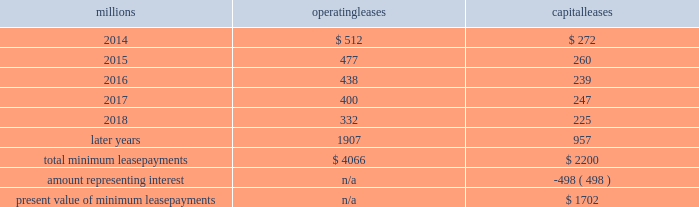On december 19 , 2011 , we redeemed the remaining $ 175 million of our 6.5% ( 6.5 % ) notes due april 15 , 2012 , and all $ 300 million of our outstanding 6.125% ( 6.125 % ) notes due january 15 , 2012 .
The redemptions resulted in an early extinguishment charge of $ 5 million in the fourth quarter of 2011 .
Receivables securitization facility 2013 as of december 31 , 2013 and 2012 , we recorded $ 0 and $ 100 million , respectively , as secured debt under our receivables securitization facility .
( see further discussion of our receivables securitization facility in note 10 ) .
15 .
Variable interest entities we have entered into various lease transactions in which the structure of the leases contain variable interest entities ( vies ) .
These vies were created solely for the purpose of doing lease transactions ( principally involving railroad equipment and facilities , including our headquarters building ) and have no other activities , assets or liabilities outside of the lease transactions .
Within these lease arrangements , we have the right to purchase some or all of the assets at fixed prices .
Depending on market conditions , fixed-price purchase options available in the leases could potentially provide benefits to us ; however , these benefits are not expected to be significant .
We maintain and operate the assets based on contractual obligations within the lease arrangements , which set specific guidelines consistent within the railroad industry .
As such , we have no control over activities that could materially impact the fair value of the leased assets .
We do not hold the power to direct the activities of the vies and , therefore , do not control the ongoing activities that have a significant impact on the economic performance of the vies .
Additionally , we do not have the obligation to absorb losses of the vies or the right to receive benefits of the vies that could potentially be significant to the we are not considered to be the primary beneficiary and do not consolidate these vies because our actions and decisions do not have the most significant effect on the vie 2019s performance and our fixed-price purchase price options are not considered to be potentially significant to the vies .
The future minimum lease payments associated with the vie leases totaled $ 3.3 billion as of december 31 , 2013 .
16 .
Leases we lease certain locomotives , freight cars , and other property .
The consolidated statements of financial position as of december 31 , 2013 and 2012 included $ 2486 million , net of $ 1092 million of accumulated depreciation , and $ 2467 million , net of $ 966 million of accumulated depreciation , respectively , for properties held under capital leases .
A charge to income resulting from the depreciation for assets held under capital leases is included within depreciation expense in our consolidated statements of income .
Future minimum lease payments for operating and capital leases with initial or remaining non-cancelable lease terms in excess of one year as of december 31 , 2013 , were as follows : millions operating leases capital leases .
Approximately 94% ( 94 % ) of capital lease payments relate to locomotives .
Rent expense for operating leases with terms exceeding one month was $ 618 million in 2013 , $ 631 million in 2012 , and $ 637 million in 2011 .
When cash rental payments are not made on a straight-line basis , we recognize variable rental expense on a straight-line basis over the lease term .
Contingent rentals and sub-rentals are not significant. .
What was the percentage change in rent expense for operating leases with terms exceeding one month from 2011 to 2012? 
Computations: ((631 - 637) / 637)
Answer: -0.00942. 